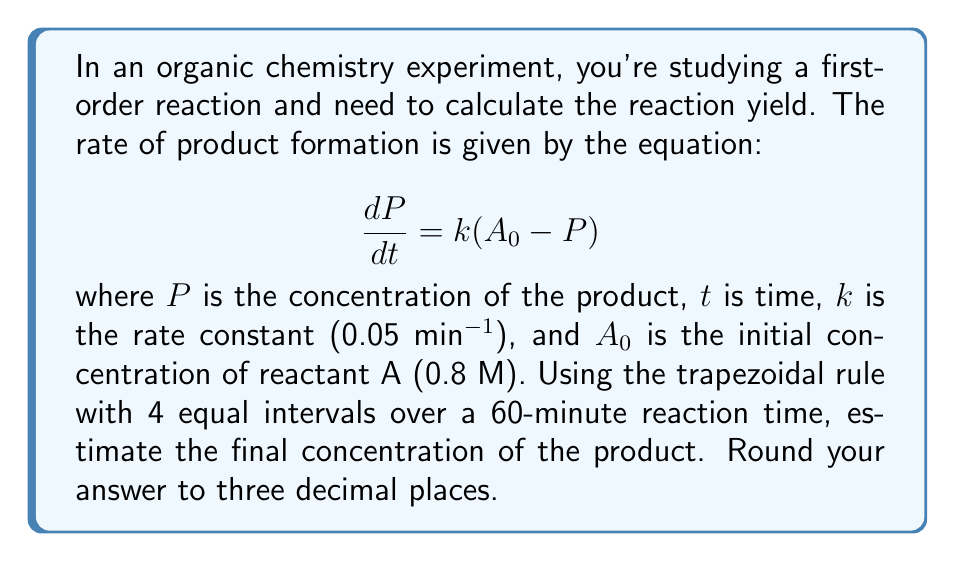Provide a solution to this math problem. To solve this problem, we'll use the trapezoidal rule for numerical integration. Here's the step-by-step process:

1) First, we need to rearrange the differential equation to isolate $dP$:

   $$dP = k(A_0 - P)dt$$

2) Now, we integrate both sides from $t=0$ to $t=60$:

   $$\int_0^{60} dP = \int_0^{60} k(A_0 - P)dt$$

3) The left side becomes $P(60) - P(0)$, which is just $P(60)$ since $P(0) = 0$. This is what we're trying to find.

4) For the right side, we'll use the trapezoidal rule with 4 intervals. The formula is:

   $$\int_a^b f(x)dx \approx \frac{h}{2}[f(x_0) + 2f(x_1) + 2f(x_2) + 2f(x_3) + f(x_4)]$$

   where $h = (b-a)/n$, $n$ is the number of intervals, and $x_i = a + ih$.

5) In our case, $h = (60-0)/4 = 15$ minutes. We need to evaluate $k(A_0 - P)$ at $t = 0, 15, 30, 45,$ and $60$ minutes.

6) To find $P$ at each time point, we can use the integrated rate law for a first-order reaction:

   $$P(t) = A_0(1 - e^{-kt})$$

7) Let's calculate $P$ and $k(A_0 - P)$ for each time point:

   $t = 0$:   $P = 0$,                    $k(A_0 - P) = 0.05(0.8 - 0) = 0.04$
   $t = 15$:  $P = 0.8(1 - e^{-0.05*15}) = 0.420$, $k(A_0 - P) = 0.05(0.8 - 0.420) = 0.019$
   $t = 30$:  $P = 0.8(1 - e^{-0.05*30}) = 0.614$, $k(A_0 - P) = 0.05(0.8 - 0.614) = 0.0093$
   $t = 45$:  $P = 0.8(1 - e^{-0.05*45}) = 0.708$, $k(A_0 - P) = 0.05(0.8 - 0.708) = 0.0046$
   $t = 60$:  $P = 0.8(1 - e^{-0.05*60}) = 0.754$, $k(A_0 - P) = 0.05(0.8 - 0.754) = 0.0023$

8) Now we can apply the trapezoidal rule:

   $$P(60) \approx \frac{15}{2}[0.04 + 2(0.019) + 2(0.0093) + 2(0.0046) + 0.0023] = 0.754$$

9) Rounding to three decimal places, we get 0.754 M.
Answer: 0.754 M 